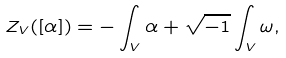<formula> <loc_0><loc_0><loc_500><loc_500>Z _ { V } ( [ \alpha ] ) = - \int _ { V } \alpha + \sqrt { - 1 } \int _ { V } \omega ,</formula> 